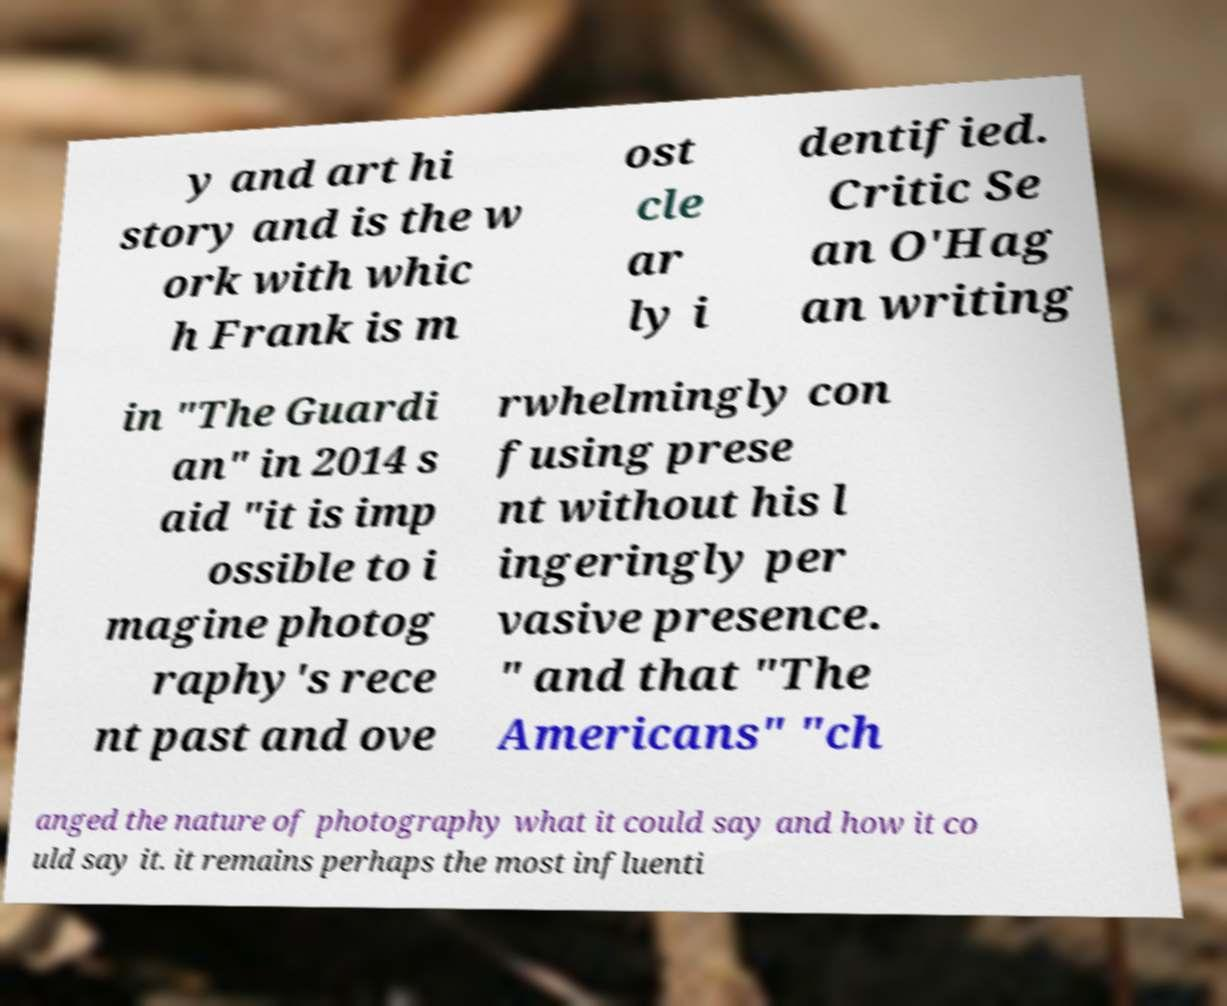For documentation purposes, I need the text within this image transcribed. Could you provide that? y and art hi story and is the w ork with whic h Frank is m ost cle ar ly i dentified. Critic Se an O'Hag an writing in "The Guardi an" in 2014 s aid "it is imp ossible to i magine photog raphy's rece nt past and ove rwhelmingly con fusing prese nt without his l ingeringly per vasive presence. " and that "The Americans" "ch anged the nature of photography what it could say and how it co uld say it. it remains perhaps the most influenti 